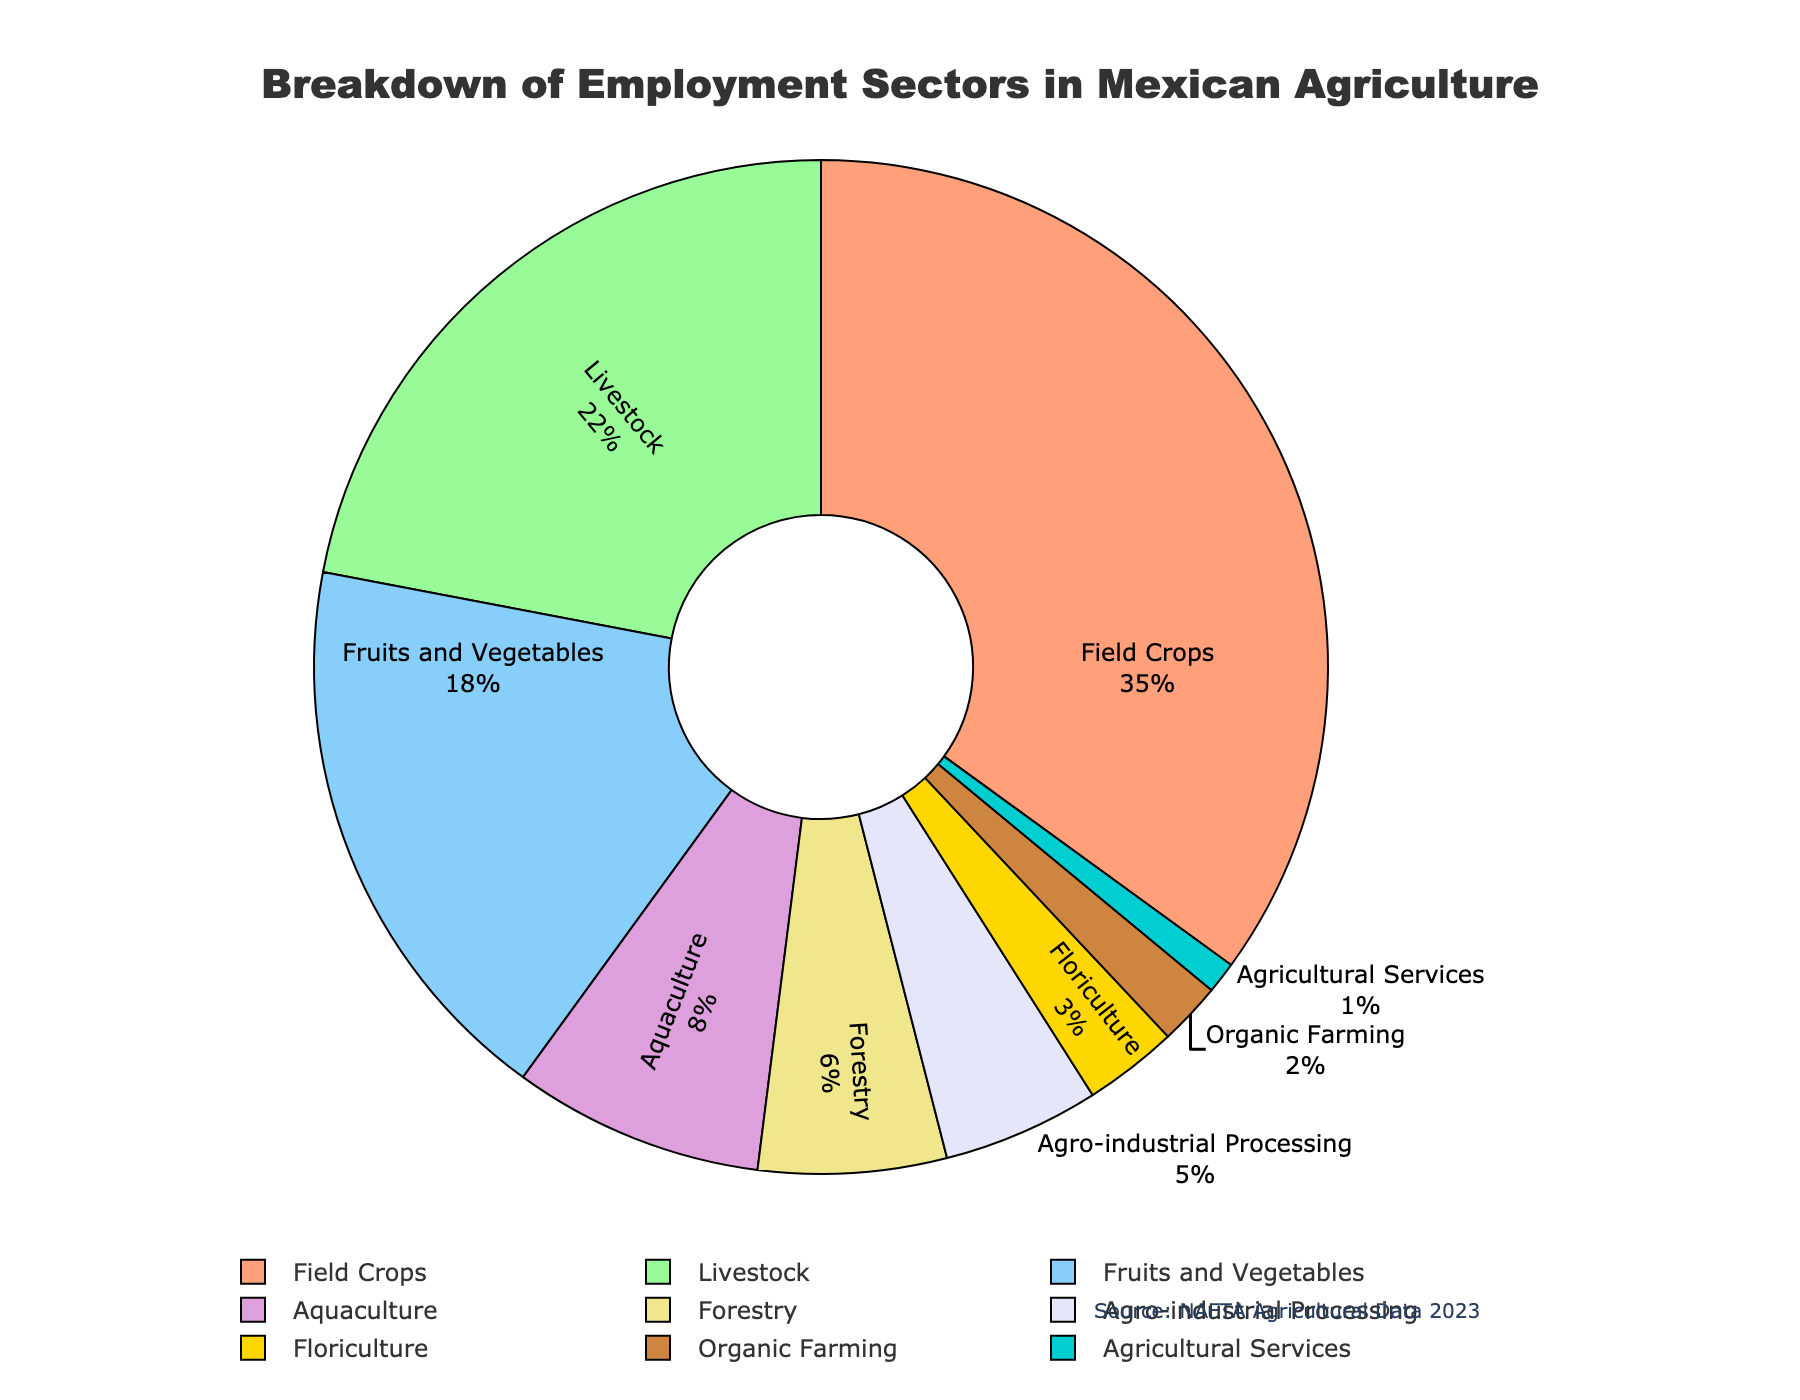What's the largest employment sector in Mexican agriculture? To find the largest employment sector, look for the segment with the highest percentage. The "Field Crops" sector has the highest value at 35%.
Answer: Field Crops Which sector employs more people, Floriculture or Aquaculture? Compare the percentages of Floriculture and Aquaculture. Floriculture has 3%, and Aquaculture has 8%, so Aquaculture employs more people.
Answer: Aquaculture What is the combined percentage of the Field Crops and Livestock sectors? Sum the percentages of Field Crops (35%) and Livestock (22%). 35 + 22 = 57%.
Answer: 57% Is the percentage of Agro-industrial Processing greater than that of Forestry? Compare the percentages of Agro-industrial Processing and Forestry. Agro-industrial Processing is 5%, and Forestry is 6%. Agro-industrial Processing is not greater.
Answer: No How does the percentage of Organic Farming compare to that of Agricultural Services? Compare the percentages of Organic Farming and Agricultural Services. Organic Farming is 2%, and Agricultural Services is 1%. Organic Farming is twice as much as Agricultural Services.
Answer: Organic Farming is greater Which sector is represented by the color gold? Identify the sector associated with the color gold on the pie chart. The "Fruits and Vegetables" sector is represented by the color gold.
Answer: Fruits and Vegetables What's the difference in percentage between Livestock and Fruits and Vegetables sectors? Find the difference between the percentages of Livestock (22%) and Fruits and Vegetables (18%). 22 - 18 = 4%.
Answer: 4% Of the sectors listed, how many have a percentage below 10%? Identify sectors with percentages below 10%: Aquaculture (8%), Forestry (6%), Agro-industrial Processing (5%), Floriculture (3%), Organic Farming (2%), and Agricultural Services (1%). There are 6 sectors below 10%.
Answer: 6 What is the total percentage represented by all sectors with less than 5%? Sum the percentages of sectors with less than 5%: Floriculture (3%), Organic Farming (2%), and Agricultural Services (1%). 3 + 2 + 1 = 6%.
Answer: 6% Which sector's segment in the pie chart is colored purple? Identify the sector represented by the purple color. The "Aquaculture" sector is colored purple.
Answer: Aquaculture 